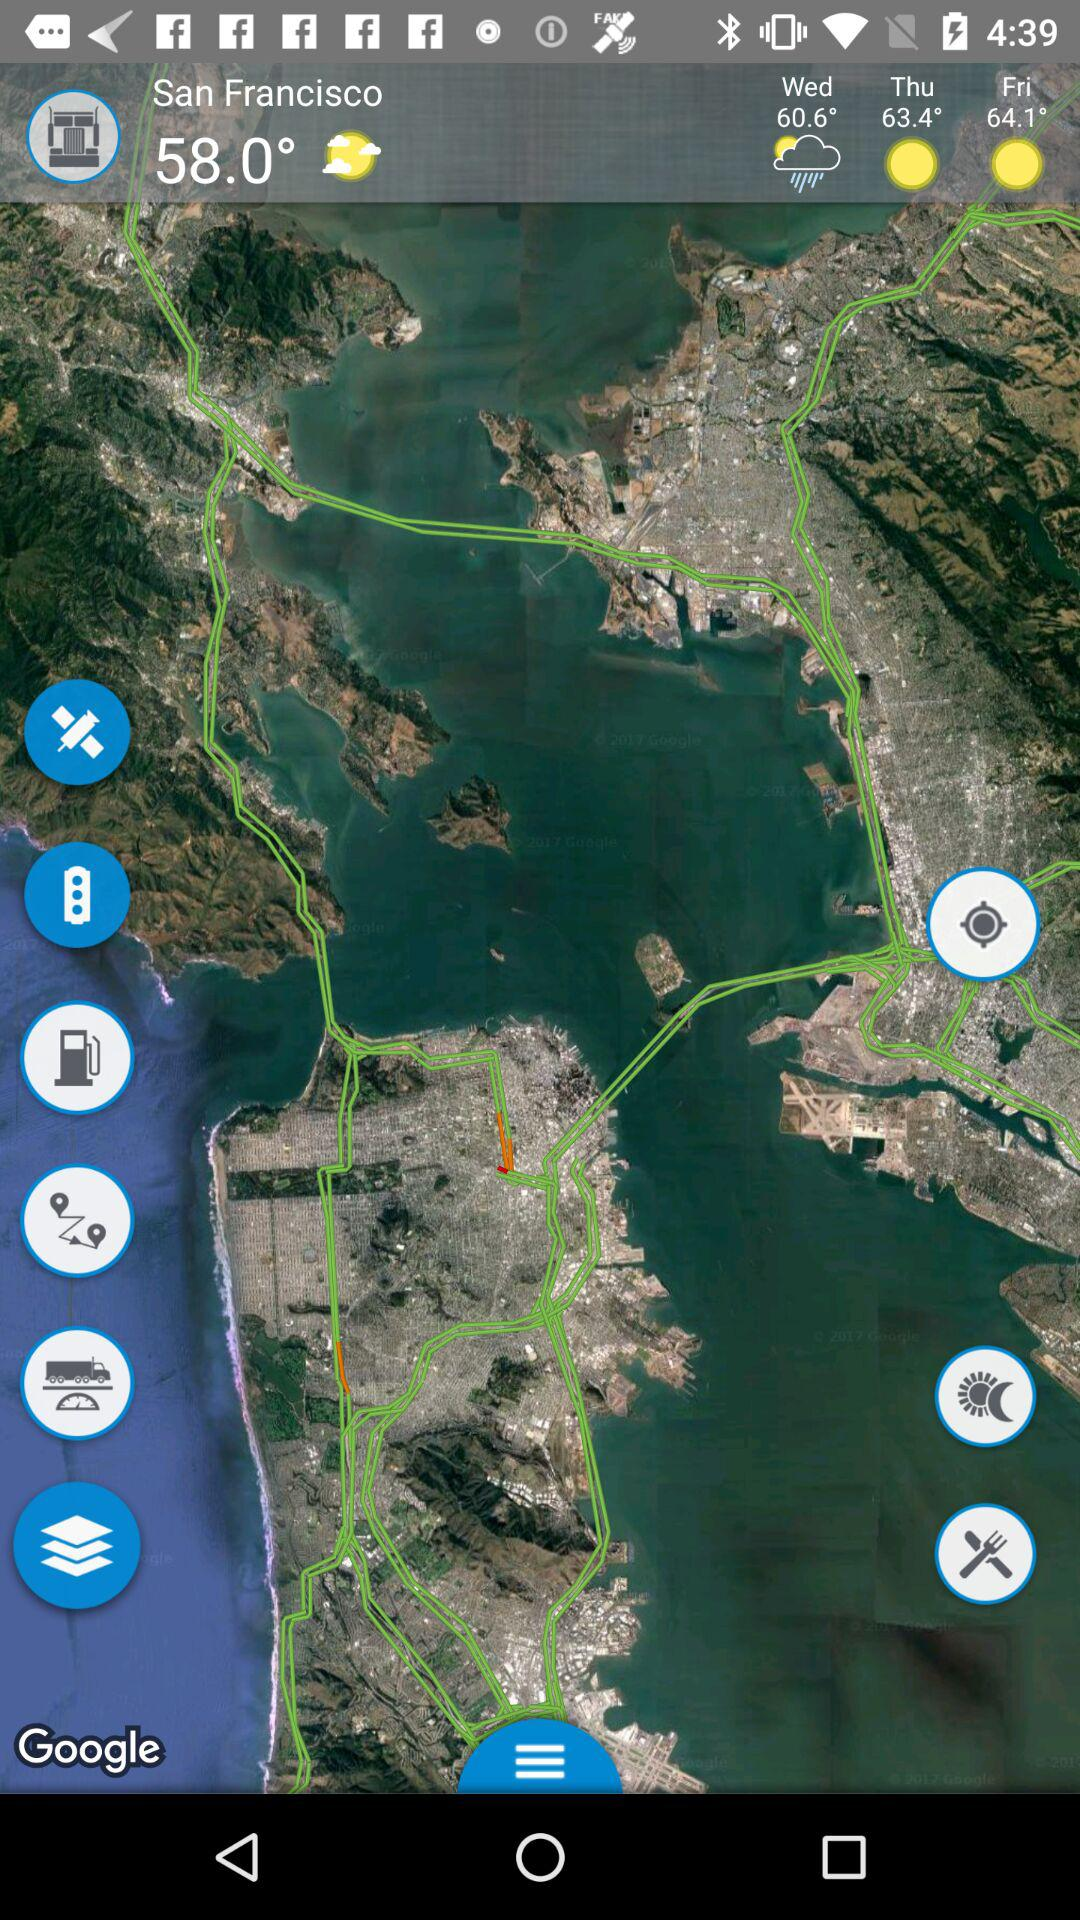What will be the temperature on Wednesday? The temperature on Wednesday will be 60.6°. 